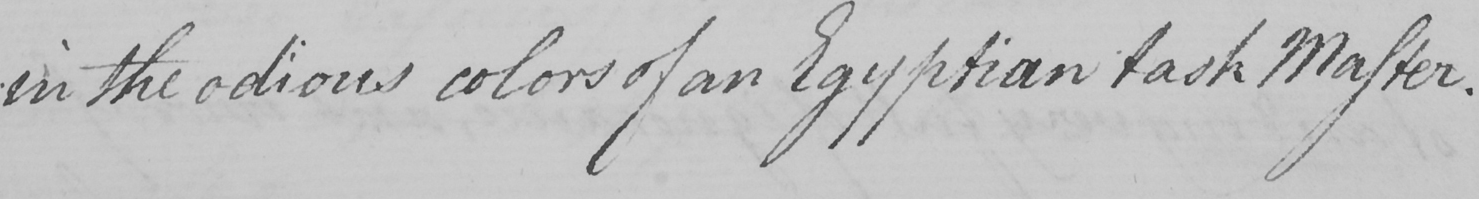What is written in this line of handwriting? in the odious colors of an Egyptian task Master . 